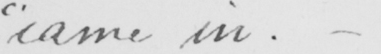What does this handwritten line say? " came in .  _ 